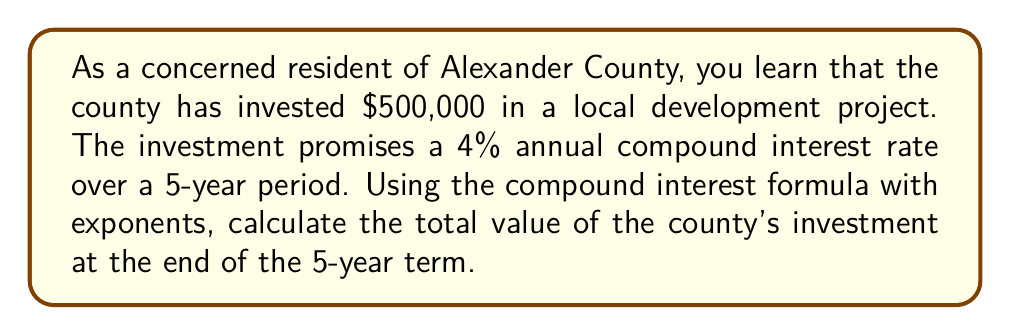Provide a solution to this math problem. To solve this problem, we'll use the compound interest formula:

$$ A = P(1 + r)^n $$

Where:
$A$ = Final amount
$P$ = Principal (initial investment)
$r$ = Annual interest rate (in decimal form)
$n$ = Number of years

Given:
$P = \$500,000$
$r = 4\% = 0.04$
$n = 5$ years

Let's substitute these values into the formula:

$$ A = 500,000(1 + 0.04)^5 $$

Now, let's solve step by step:

1) First, calculate $(1 + 0.04)^5$:
   $$ (1.04)^5 = 1.2166529... $$

2) Multiply this result by the principal:
   $$ 500,000 \times 1.2166529... = 608,326.45... $$

3) Round to the nearest cent:
   $$ 608,326.45 $$

Therefore, the total value of the county's investment after 5 years will be $608,326.45.
Answer: $608,326.45 